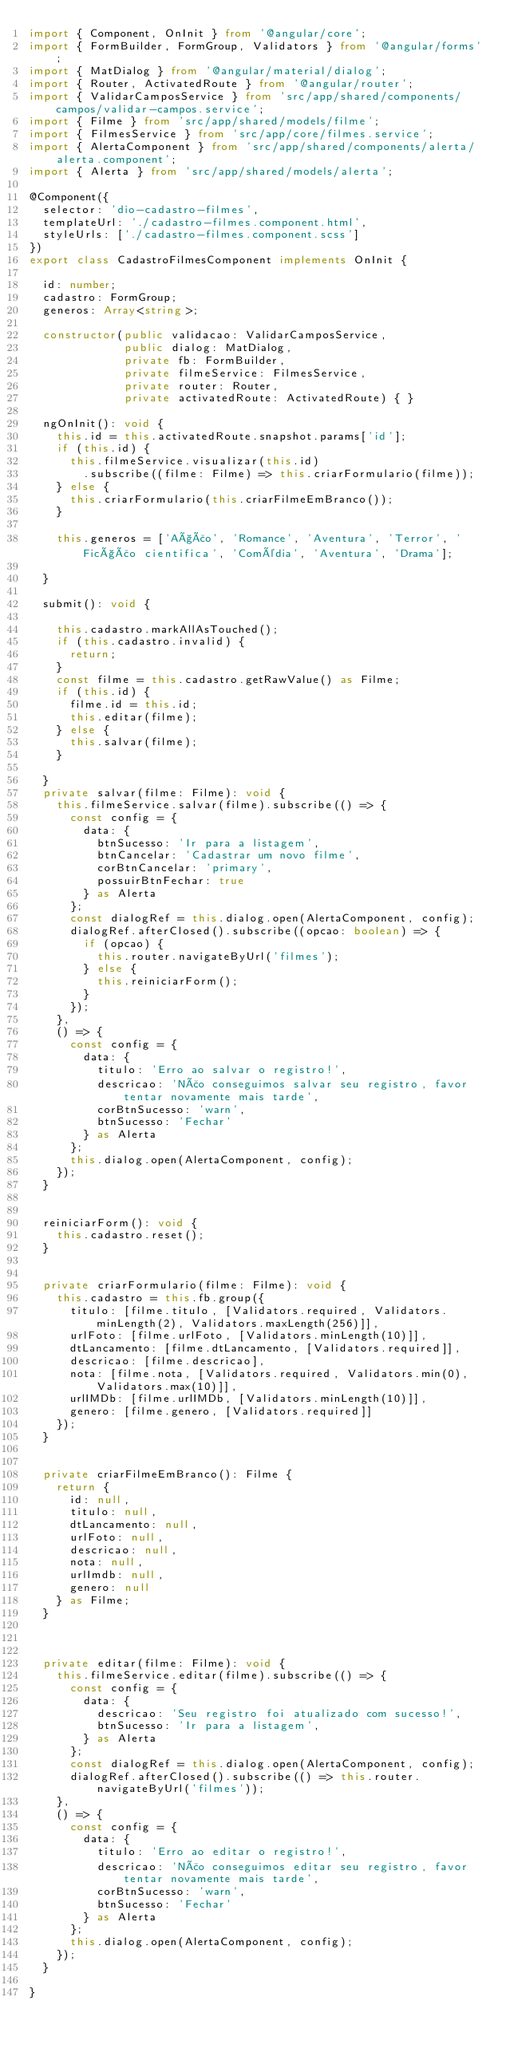<code> <loc_0><loc_0><loc_500><loc_500><_TypeScript_>import { Component, OnInit } from '@angular/core';
import { FormBuilder, FormGroup, Validators } from '@angular/forms';
import { MatDialog } from '@angular/material/dialog';
import { Router, ActivatedRoute } from '@angular/router';
import { ValidarCamposService } from 'src/app/shared/components/campos/validar-campos.service';
import { Filme } from 'src/app/shared/models/filme';
import { FilmesService } from 'src/app/core/filmes.service';
import { AlertaComponent } from 'src/app/shared/components/alerta/alerta.component';
import { Alerta } from 'src/app/shared/models/alerta';

@Component({
  selector: 'dio-cadastro-filmes',
  templateUrl: './cadastro-filmes.component.html',
  styleUrls: ['./cadastro-filmes.component.scss']
})
export class CadastroFilmesComponent implements OnInit {

  id: number;
  cadastro: FormGroup;
  generos: Array<string>;

  constructor(public validacao: ValidarCamposService,
              public dialog: MatDialog,
              private fb: FormBuilder,
              private filmeService: FilmesService,
              private router: Router,
              private activatedRoute: ActivatedRoute) { }

  ngOnInit(): void {
    this.id = this.activatedRoute.snapshot.params['id'];
    if (this.id) {
      this.filmeService.visualizar(this.id)
        .subscribe((filme: Filme) => this.criarFormulario(filme));
    } else {
      this.criarFormulario(this.criarFilmeEmBranco());
    }

    this.generos = ['Ação', 'Romance', 'Aventura', 'Terror', 'Ficção cientifica', 'Comédia', 'Aventura', 'Drama'];

  }

  submit(): void {

    this.cadastro.markAllAsTouched();
    if (this.cadastro.invalid) {
      return;
    }
    const filme = this.cadastro.getRawValue() as Filme;
    if (this.id) {
      filme.id = this.id;
      this.editar(filme);
    } else {
      this.salvar(filme);
    }

  }
  private salvar(filme: Filme): void {
    this.filmeService.salvar(filme).subscribe(() => {
      const config = {
        data: {
          btnSucesso: 'Ir para a listagem',
          btnCancelar: 'Cadastrar um novo filme',
          corBtnCancelar: 'primary',
          possuirBtnFechar: true
        } as Alerta
      };
      const dialogRef = this.dialog.open(AlertaComponent, config);
      dialogRef.afterClosed().subscribe((opcao: boolean) => {
        if (opcao) {
          this.router.navigateByUrl('filmes');
        } else {
          this.reiniciarForm();
        }
      });
    },
    () => {
      const config = {
        data: {
          titulo: 'Erro ao salvar o registro!',
          descricao: 'Não conseguimos salvar seu registro, favor tentar novamente mais tarde',
          corBtnSucesso: 'warn',
          btnSucesso: 'Fechar'
        } as Alerta
      };
      this.dialog.open(AlertaComponent, config);
    });
  }


  reiniciarForm(): void {
    this.cadastro.reset();
  }


  private criarFormulario(filme: Filme): void {
    this.cadastro = this.fb.group({
      titulo: [filme.titulo, [Validators.required, Validators.minLength(2), Validators.maxLength(256)]],
      urlFoto: [filme.urlFoto, [Validators.minLength(10)]],
      dtLancamento: [filme.dtLancamento, [Validators.required]],
      descricao: [filme.descricao],
      nota: [filme.nota, [Validators.required, Validators.min(0), Validators.max(10)]],
      urlIMDb: [filme.urlIMDb, [Validators.minLength(10)]],
      genero: [filme.genero, [Validators.required]]
    });
  }


  private criarFilmeEmBranco(): Filme {
    return {
      id: null,
      titulo: null,
      dtLancamento: null,
      urlFoto: null,
      descricao: null,
      nota: null,
      urlImdb: null,
      genero: null
    } as Filme;
  }

  

  private editar(filme: Filme): void {
    this.filmeService.editar(filme).subscribe(() => {
      const config = {
        data: {
          descricao: 'Seu registro foi atualizado com sucesso!',
          btnSucesso: 'Ir para a listagem',
        } as Alerta
      };
      const dialogRef = this.dialog.open(AlertaComponent, config);
      dialogRef.afterClosed().subscribe(() => this.router.navigateByUrl('filmes'));
    },
    () => {
      const config = {
        data: {
          titulo: 'Erro ao editar o registro!',
          descricao: 'Não conseguimos editar seu registro, favor tentar novamente mais tarde',
          corBtnSucesso: 'warn',
          btnSucesso: 'Fechar'
        } as Alerta
      };
      this.dialog.open(AlertaComponent, config);
    });
  }

}
</code> 